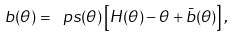Convert formula to latex. <formula><loc_0><loc_0><loc_500><loc_500>b ( \theta ) = \ p s ( \theta ) \left [ H ( \theta ) - \theta + \bar { b } ( \theta ) \right ] ,</formula> 